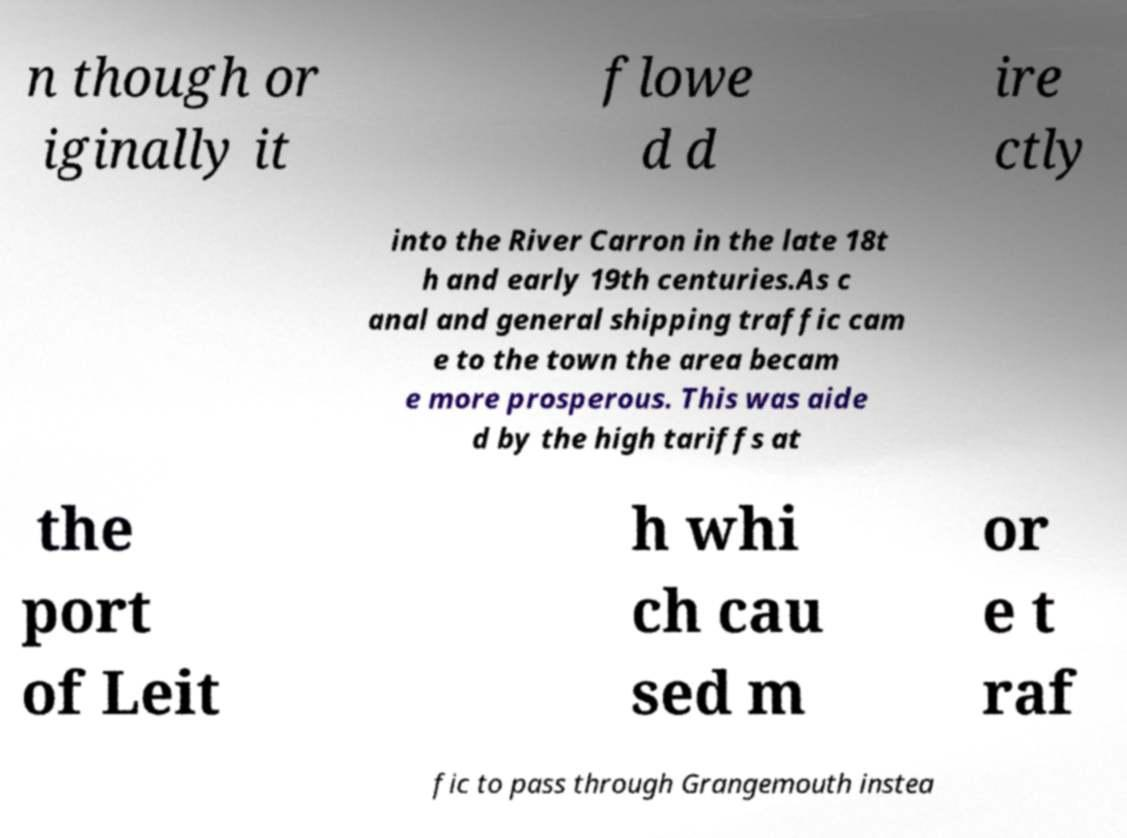Please identify and transcribe the text found in this image. n though or iginally it flowe d d ire ctly into the River Carron in the late 18t h and early 19th centuries.As c anal and general shipping traffic cam e to the town the area becam e more prosperous. This was aide d by the high tariffs at the port of Leit h whi ch cau sed m or e t raf fic to pass through Grangemouth instea 